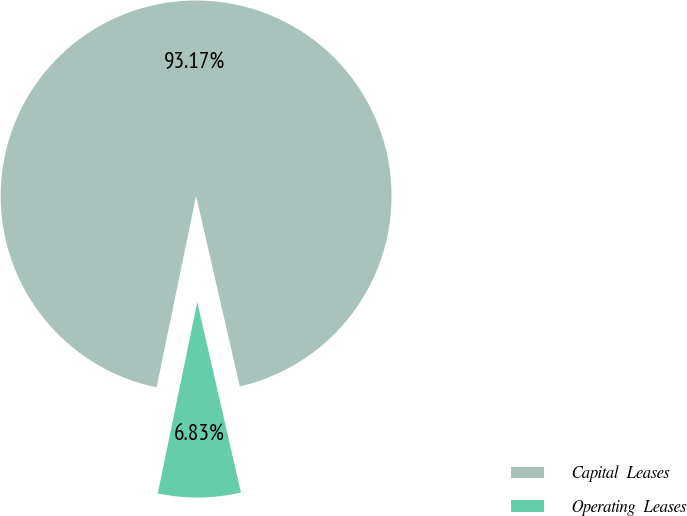<chart> <loc_0><loc_0><loc_500><loc_500><pie_chart><fcel>Capital  Leases<fcel>Operating  Leases<nl><fcel>93.17%<fcel>6.83%<nl></chart> 